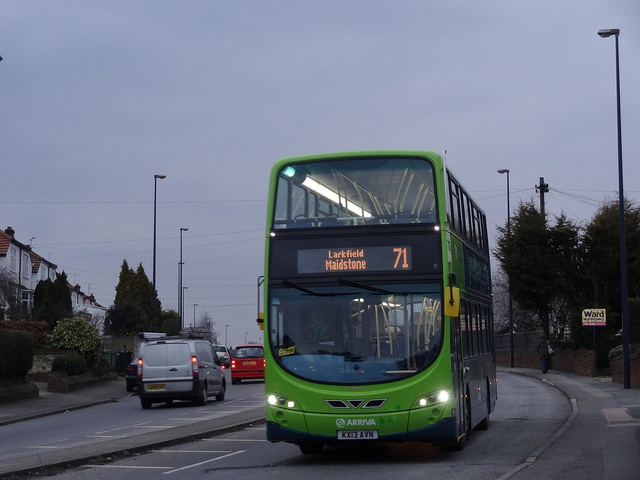Describe the objects in this image and their specific colors. I can see bus in darkgray, black, gray, darkgreen, and navy tones, truck in darkgray, black, and gray tones, car in darkgray, maroon, black, gray, and brown tones, people in darkgray, black, and gray tones, and people in black, gray, and darkgray tones in this image. 